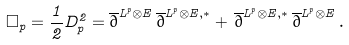<formula> <loc_0><loc_0><loc_500><loc_500>\square _ { p } = \frac { 1 } { 2 } D ^ { 2 } _ { p } = \overline { \partial } ^ { L ^ { p } \otimes E } \, \overline { \partial } ^ { L ^ { p } \otimes E , * } + \, \overline { \partial } ^ { L ^ { p } \otimes E , * } \, \overline { \partial } ^ { L ^ { p } \otimes E } \, .</formula> 